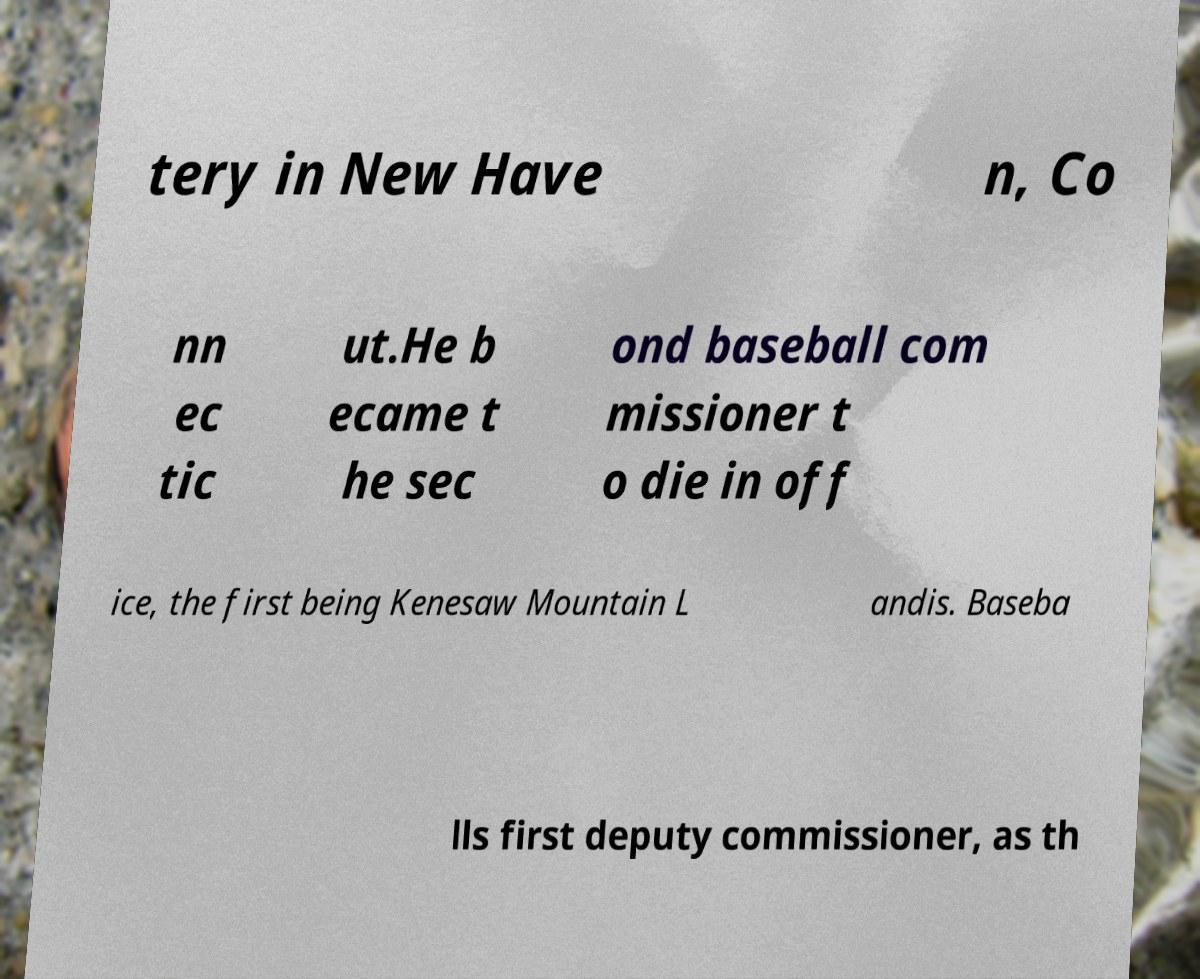For documentation purposes, I need the text within this image transcribed. Could you provide that? tery in New Have n, Co nn ec tic ut.He b ecame t he sec ond baseball com missioner t o die in off ice, the first being Kenesaw Mountain L andis. Baseba lls first deputy commissioner, as th 